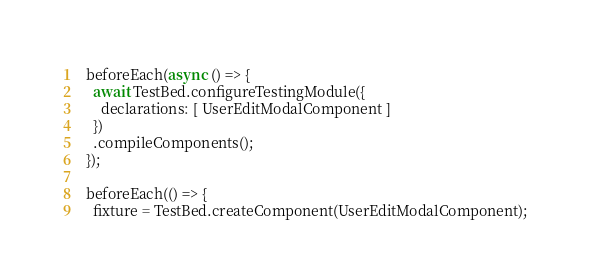Convert code to text. <code><loc_0><loc_0><loc_500><loc_500><_TypeScript_>  beforeEach(async () => {
    await TestBed.configureTestingModule({
      declarations: [ UserEditModalComponent ]
    })
    .compileComponents();
  });

  beforeEach(() => {
    fixture = TestBed.createComponent(UserEditModalComponent);</code> 